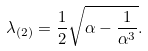<formula> <loc_0><loc_0><loc_500><loc_500>\lambda _ { ( 2 ) } = \frac { 1 } { 2 } \sqrt { \alpha - \frac { 1 } { \alpha ^ { 3 } } } .</formula> 